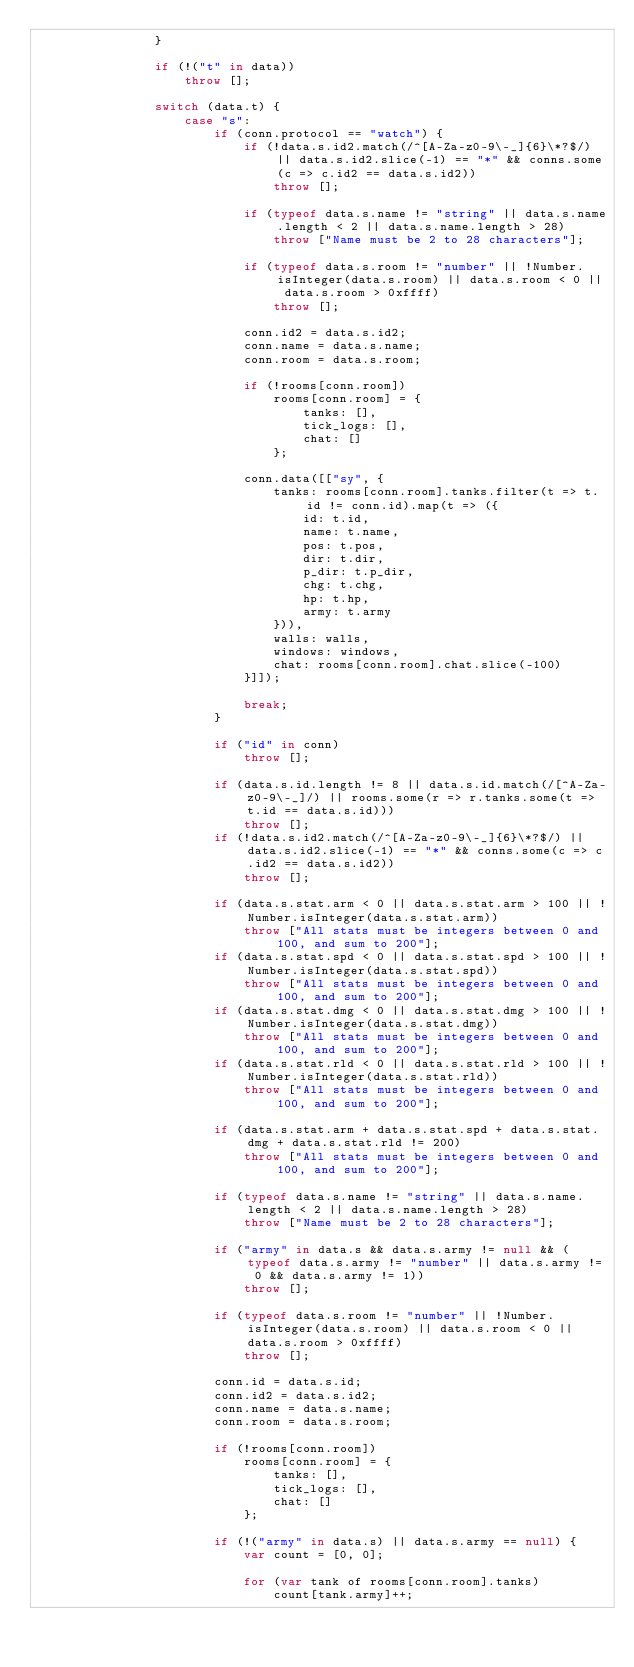Convert code to text. <code><loc_0><loc_0><loc_500><loc_500><_JavaScript_>                }
                
                if (!("t" in data))
                    throw [];
                
                switch (data.t) {
                    case "s":
                        if (conn.protocol == "watch") {
                            if (!data.s.id2.match(/^[A-Za-z0-9\-_]{6}\*?$/) || data.s.id2.slice(-1) == "*" && conns.some(c => c.id2 == data.s.id2))
                                throw [];
                            
                            if (typeof data.s.name != "string" || data.s.name.length < 2 || data.s.name.length > 28)
                                throw ["Name must be 2 to 28 characters"];
                            
                            if (typeof data.s.room != "number" || !Number.isInteger(data.s.room) || data.s.room < 0 || data.s.room > 0xffff)
                                throw [];

                            conn.id2 = data.s.id2;
                            conn.name = data.s.name;
                            conn.room = data.s.room;

                            if (!rooms[conn.room])
                                rooms[conn.room] = {
                                    tanks: [],
                                    tick_logs: [],
                                    chat: []
                                };
                            
                            conn.data([["sy", {
                                tanks: rooms[conn.room].tanks.filter(t => t.id != conn.id).map(t => ({
                                    id: t.id,
                                    name: t.name,
                                    pos: t.pos,
                                    dir: t.dir,
                                    p_dir: t.p_dir,
                                    chg: t.chg,
                                    hp: t.hp,
                                    army: t.army
                                })),
                                walls: walls,
                                windows: windows,
                                chat: rooms[conn.room].chat.slice(-100)
                            }]]);
                            
                            break;
                        }
                        
                        if ("id" in conn)
                            throw [];
                        
                        if (data.s.id.length != 8 || data.s.id.match(/[^A-Za-z0-9\-_]/) || rooms.some(r => r.tanks.some(t => t.id == data.s.id)))
                            throw [];
                        if (!data.s.id2.match(/^[A-Za-z0-9\-_]{6}\*?$/) || data.s.id2.slice(-1) == "*" && conns.some(c => c.id2 == data.s.id2))
                            throw [];

                        if (data.s.stat.arm < 0 || data.s.stat.arm > 100 || !Number.isInteger(data.s.stat.arm))
                            throw ["All stats must be integers between 0 and 100, and sum to 200"];
                        if (data.s.stat.spd < 0 || data.s.stat.spd > 100 || !Number.isInteger(data.s.stat.spd))
                            throw ["All stats must be integers between 0 and 100, and sum to 200"];
                        if (data.s.stat.dmg < 0 || data.s.stat.dmg > 100 || !Number.isInteger(data.s.stat.dmg))
                            throw ["All stats must be integers between 0 and 100, and sum to 200"];
                        if (data.s.stat.rld < 0 || data.s.stat.rld > 100 || !Number.isInteger(data.s.stat.rld))
                            throw ["All stats must be integers between 0 and 100, and sum to 200"];
                        
                        if (data.s.stat.arm + data.s.stat.spd + data.s.stat.dmg + data.s.stat.rld != 200)
                            throw ["All stats must be integers between 0 and 100, and sum to 200"];
                        
                        if (typeof data.s.name != "string" || data.s.name.length < 2 || data.s.name.length > 28)
                            throw ["Name must be 2 to 28 characters"];
                        
                        if ("army" in data.s && data.s.army != null && (typeof data.s.army != "number" || data.s.army != 0 && data.s.army != 1))
                            throw [];
                            
                        if (typeof data.s.room != "number" || !Number.isInteger(data.s.room) || data.s.room < 0 || data.s.room > 0xffff)
                            throw [];

                        conn.id = data.s.id;
                        conn.id2 = data.s.id2;
                        conn.name = data.s.name;
                        conn.room = data.s.room;

                        if (!rooms[conn.room])
                            rooms[conn.room] = {
                                tanks: [],
                                tick_logs: [],
                                chat: []
                            };

                        if (!("army" in data.s) || data.s.army == null) {
                            var count = [0, 0];

                            for (var tank of rooms[conn.room].tanks)
                                count[tank.army]++;
</code> 